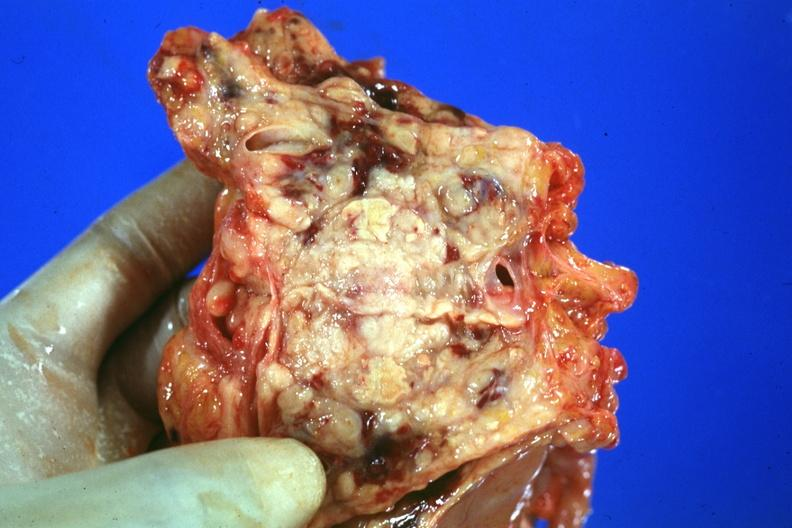how is prostate cut open showing neoplasm quite?
Answer the question using a single word or phrase. Good 